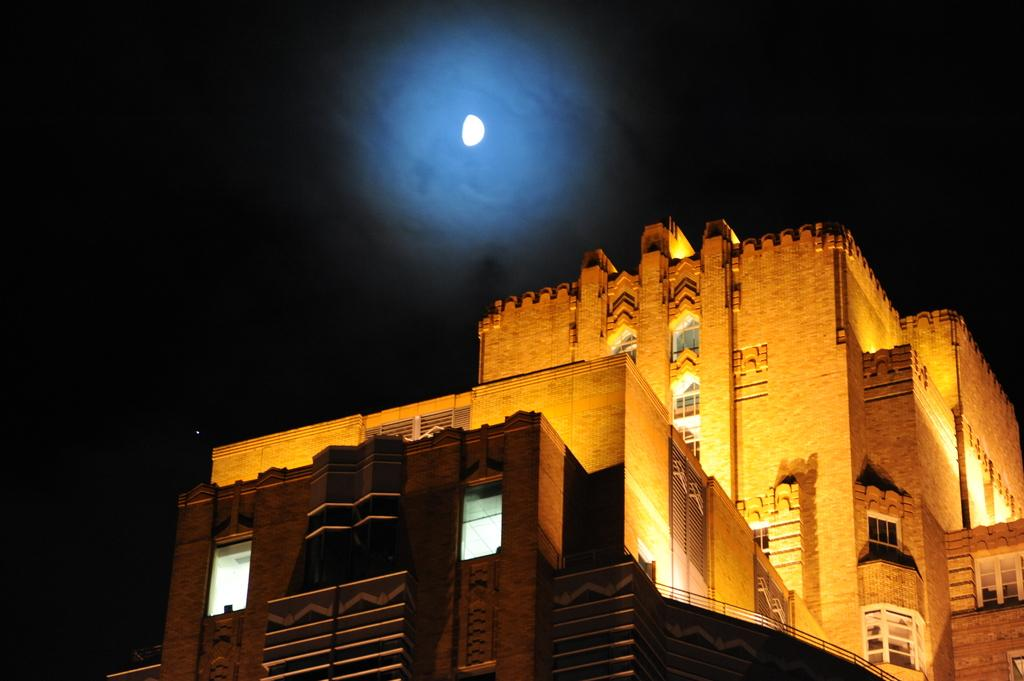What is the main structure in the image? There is a building in the image. What feature can be seen on the building? The building has windows. What celestial body is visible in the sky in the background of the image? The moon is visible in the sky in the background of the image. How many horses can be seen inside the building in the image? There are no horses present in the image, as it features a building with windows and the moon in the sky. 